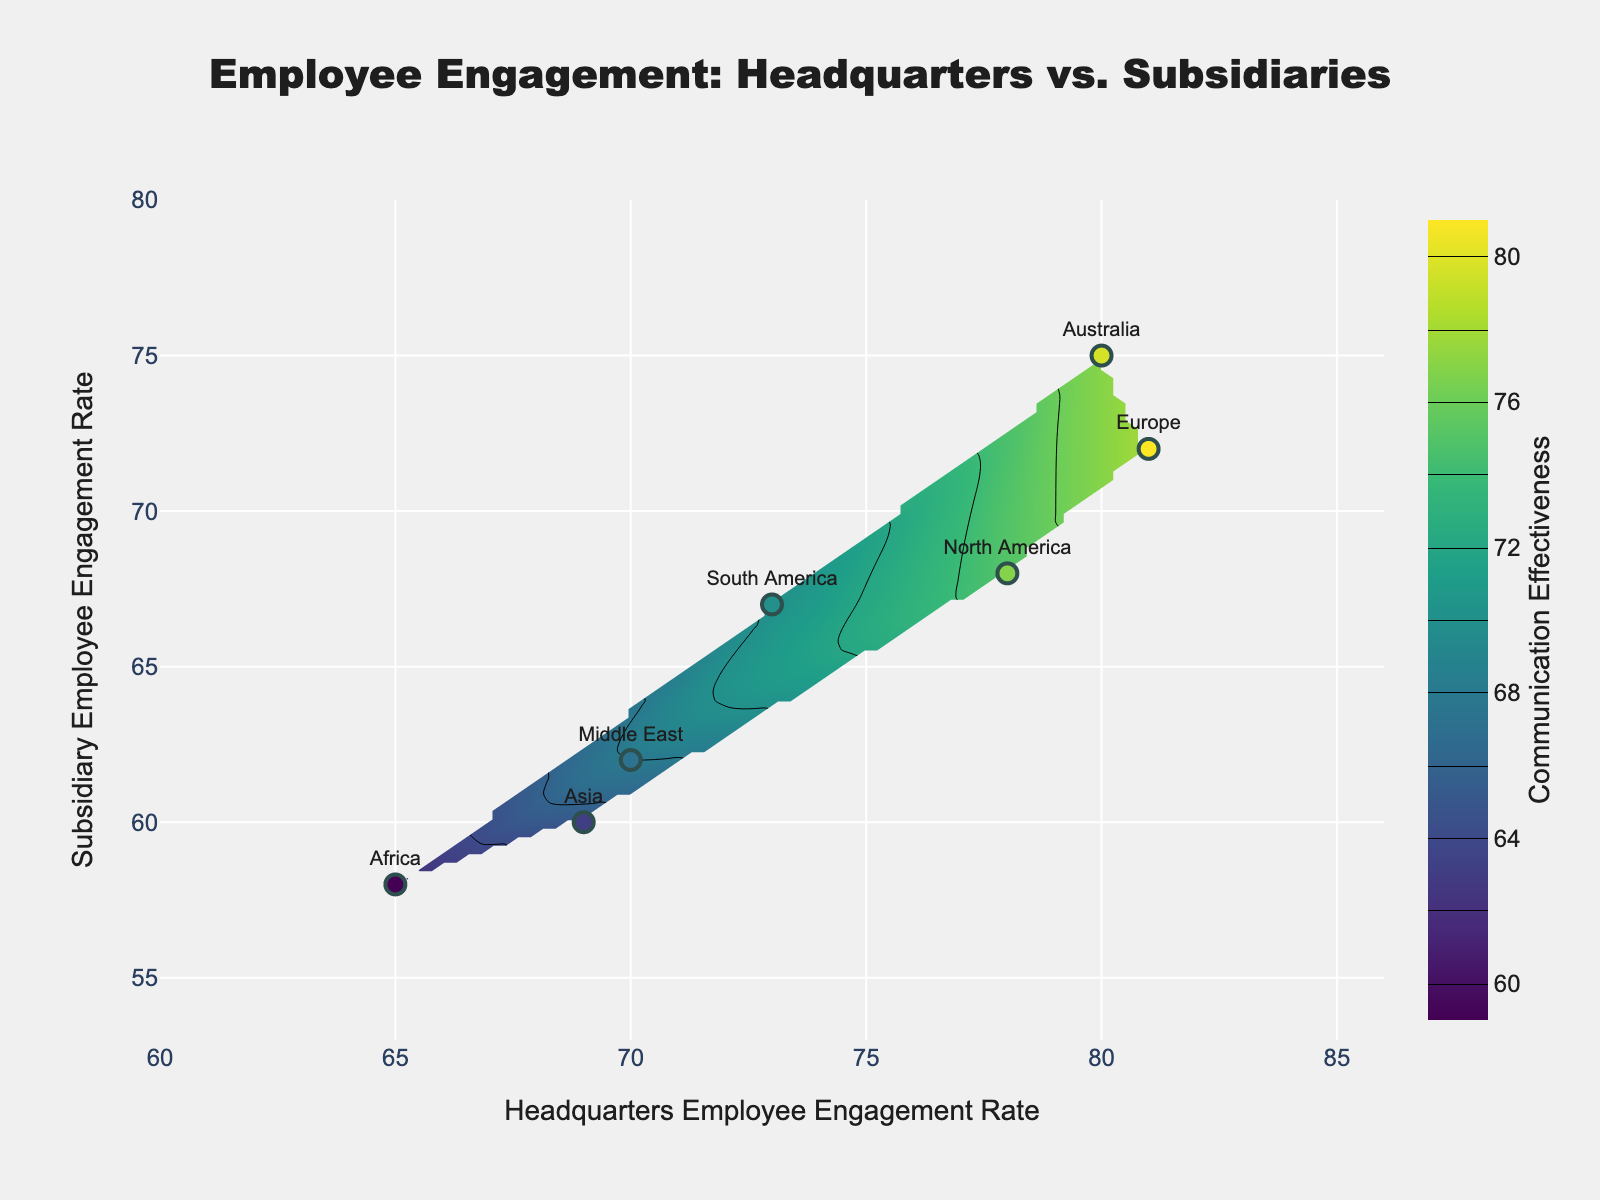What's the title of the plot? The title of the plot is displayed at the top center of the figure and reads: "Employee Engagement: Headquarters vs. Subsidiaries".
Answer: Employee Engagement: Headquarters vs. Subsidiaries What does the x-axis represent? The x-axis represents the Headquarters Employee Engagement Rate. This is inferred from the x-axis title directly under the axis.
Answer: Headquarters Employee Engagement Rate Which region has the highest subsidiary employee engagement rate? By looking at the y-axis positions of the scatter points labeled with the region names, Australia has the highest value on the y-axis.
Answer: Australia What is the range of Communication Effectiveness shown in the color bar? The color bar on the right side of the plot shows a range from 60 to 80 for Communication Effectiveness.
Answer: 60 to 80 How do North America's engagement rates compare between headquarters and subsidiaries? Referring to the North America label on the plot, its headquarters rate is at 78, and its subsidiary rate is at 68.
Answer: Headquarters: 78, Subsidiary: 68 Which region shows the largest difference in employee engagement rates between headquarters and subsidiaries? By comparing the distances between points on the x and y axes, Africa shows the largest gap between headquarters (65) and subsidiary (58) rates.
Answer: Africa Where is the effectiveness of communication highest, and which region does it correspond to? The highest value in the color bar is 80, which points to excellence in Australia (75).
Answer: Australia Consider North America and Europe, which has higher communication effectiveness? According to their positions and color gradients on the contour, Europe (78) has slightly higher effectiveness than North America (75).
Answer: Europe What is the general trend of communication effectiveness regarding engagement rates between headquarters and subsidiaries? Observing the contours, as the employee engagement rates in both headquarters and subsidiary increase, the communication effectiveness tends to increase as well, moving towards the 80 level.
Answer: Increases with higher engagement rates Which region's engagement rate data point lies closest to the center of the plot and what does this signify for communication effectiveness? The Middle East data point lies closest to the center, suggesting an average communication effectiveness around the central contours (around 68).
Answer: Middle East 